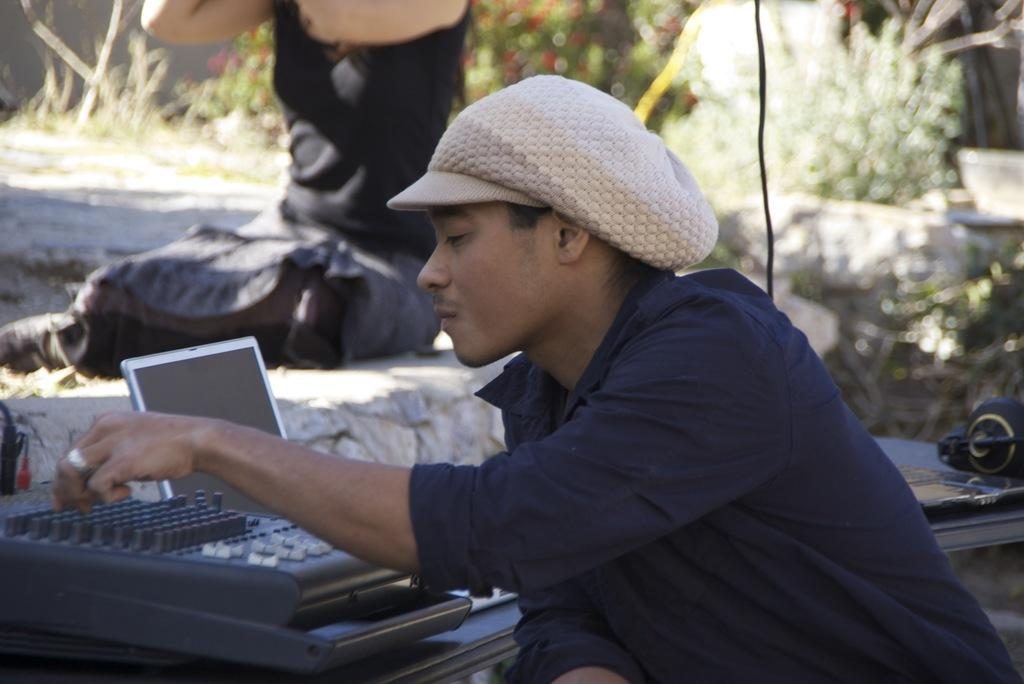What is the person holding in the image? There is a person holding something in the image, but the specific object is not mentioned in the facts. What type of electronic device can be seen in the image? There is a laptop in the image, which is a type of electronic device. What other electronic gadgets are present in the image? There are electronic gadgets in the image, but the specific gadgets are not mentioned in the facts. What is the person wearing on their head in the image? There is a headset in the image, which is worn on the person's head. What objects can be seen on the table in the image? There are objects on a table in the image, but the specific objects are not mentioned in the facts. Can you describe the background of the image? The background of the image includes a person, grass, and flowers. What flavor of shoes can be seen in the image? There are no shoes present in the image, so it is not possible to determine the flavor of any shoes. What shape is the flavor in the image? There is no flavor present in the image, so it is not possible to determine the shape of any flavor. 